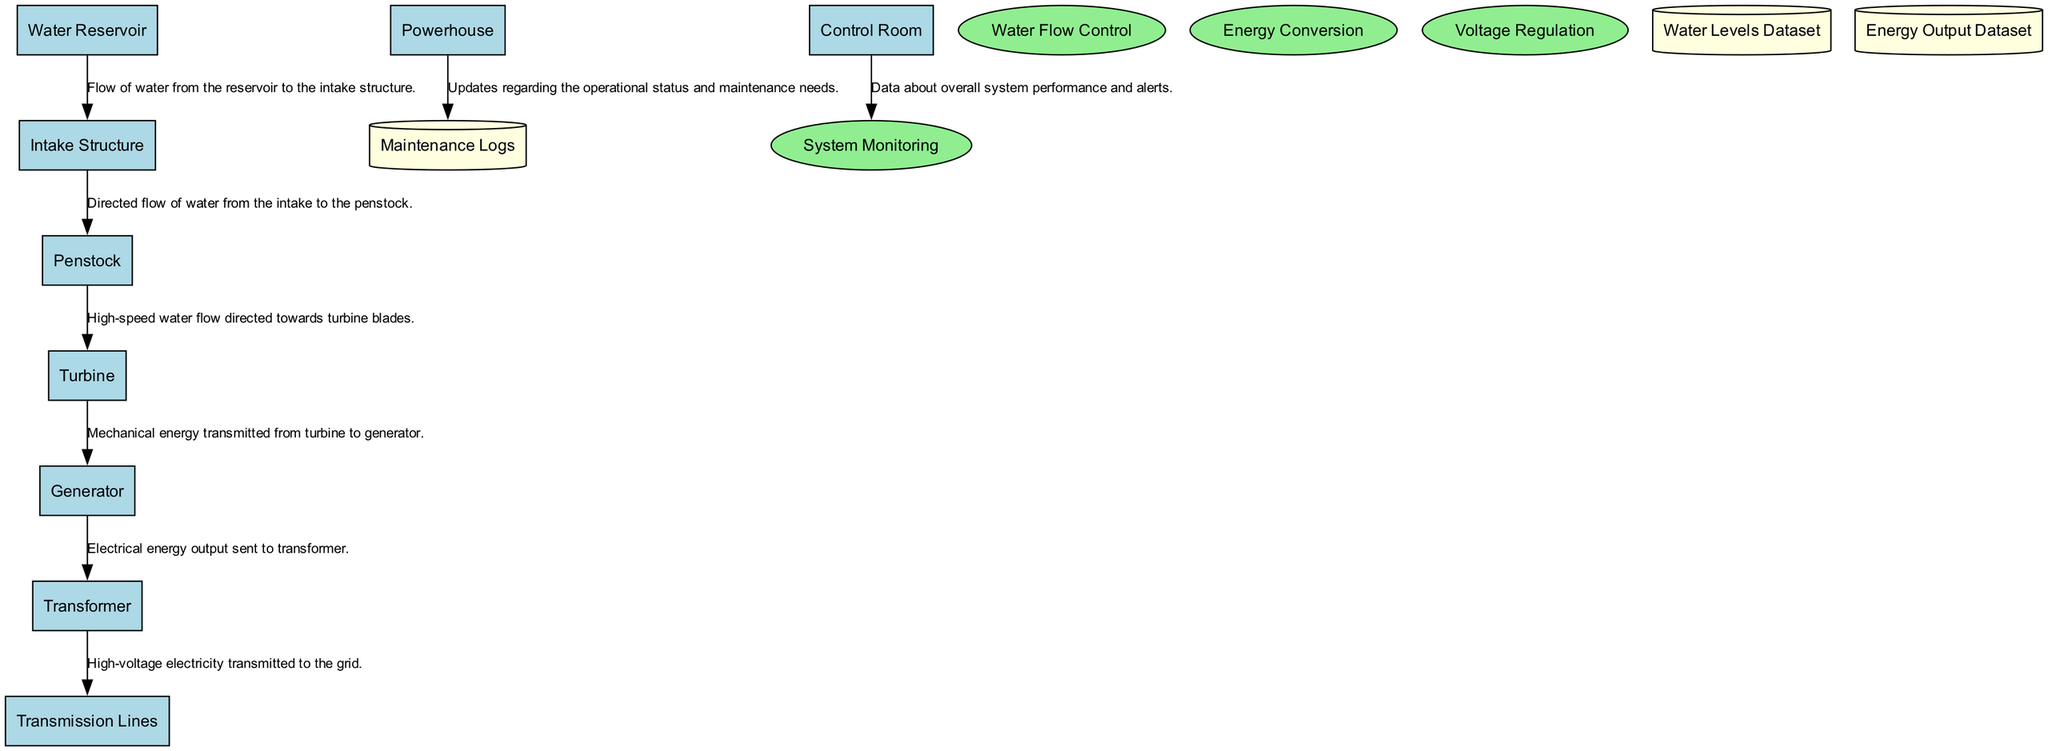What is the first entity in the diagram? The first entity in the diagram is "Water Reservoir", as it is positioned at the top of the diagram and is the starting point for the process of energy generation.
Answer: Water Reservoir How many entities are in the diagram? To find the total number of entities, we count the listed entities which include: Water Reservoir, Intake Structure, Penstock, Turbine, Generator, Powerhouse, Transformer, Transmission Lines, and Control Room. This totals to nine entities.
Answer: 9 What process is directly involved in converting energy? The process that is directly involved in converting energy in the diagram is "Energy Conversion", which explicitly mentions the conversion of kinetic energy to mechanical and electrical energy.
Answer: Energy Conversion Which entity receives the mechanical energy from the turbine? The entity that receives the mechanical energy from the turbine is the "Generator", as indicated in the flow where mechanical energy is transmitted from the turbine to the generator.
Answer: Generator What is the last element of the data flow in the diagram? The last element of the data flow is "Transmission Lines", which represents the final step of transmitting high-voltage electricity generated to the grid.
Answer: Transmission Lines Which process is responsible for monitoring the overall system performance? The process responsible for monitoring overall system performance is "System Monitoring", which oversees the operational status of the hydroelectric process from the control room.
Answer: System Monitoring What type of flow connects the Penstock and the Turbine? The type of flow connecting Penstock and Turbine is characterized as "High-speed water flow directed towards turbine blades", emphasizing the kinetic aspect of the energy conversion.
Answer: High-speed water flow directed towards turbine blades What does the Transformer do in the diagram? The Transformer is responsible for stepping up the voltage of generated electricity for efficient transmission, indicating its critical role in preparing electricity for the grid.
Answer: Steps up the voltage How does the Control Room interact with the System Monitoring process? The Control Room provides data about overall system performance and alerts to the System Monitoring process, indicating a continuous loop of information that ensures proper oversight.
Answer: Provides data about overall system performance and alerts How many data stores are present in the diagram? To find the number of data stores, we count: Water Levels Dataset, Energy Output Dataset, and Maintenance Logs, which totals to three data stores in the diagram.
Answer: 3 